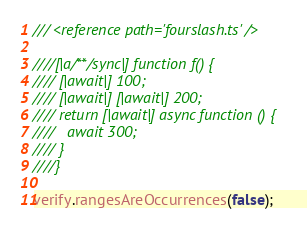Convert code to text. <code><loc_0><loc_0><loc_500><loc_500><_TypeScript_>/// <reference path='fourslash.ts' />

////[|a/**/sync|] function f() {
//// [|await|] 100;
//// [|await|] [|await|] 200;
//// return [|await|] async function () {
////   await 300;
//// }
////}

verify.rangesAreOccurrences(false);
</code> 